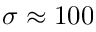<formula> <loc_0><loc_0><loc_500><loc_500>\sigma \approx 1 0 0</formula> 